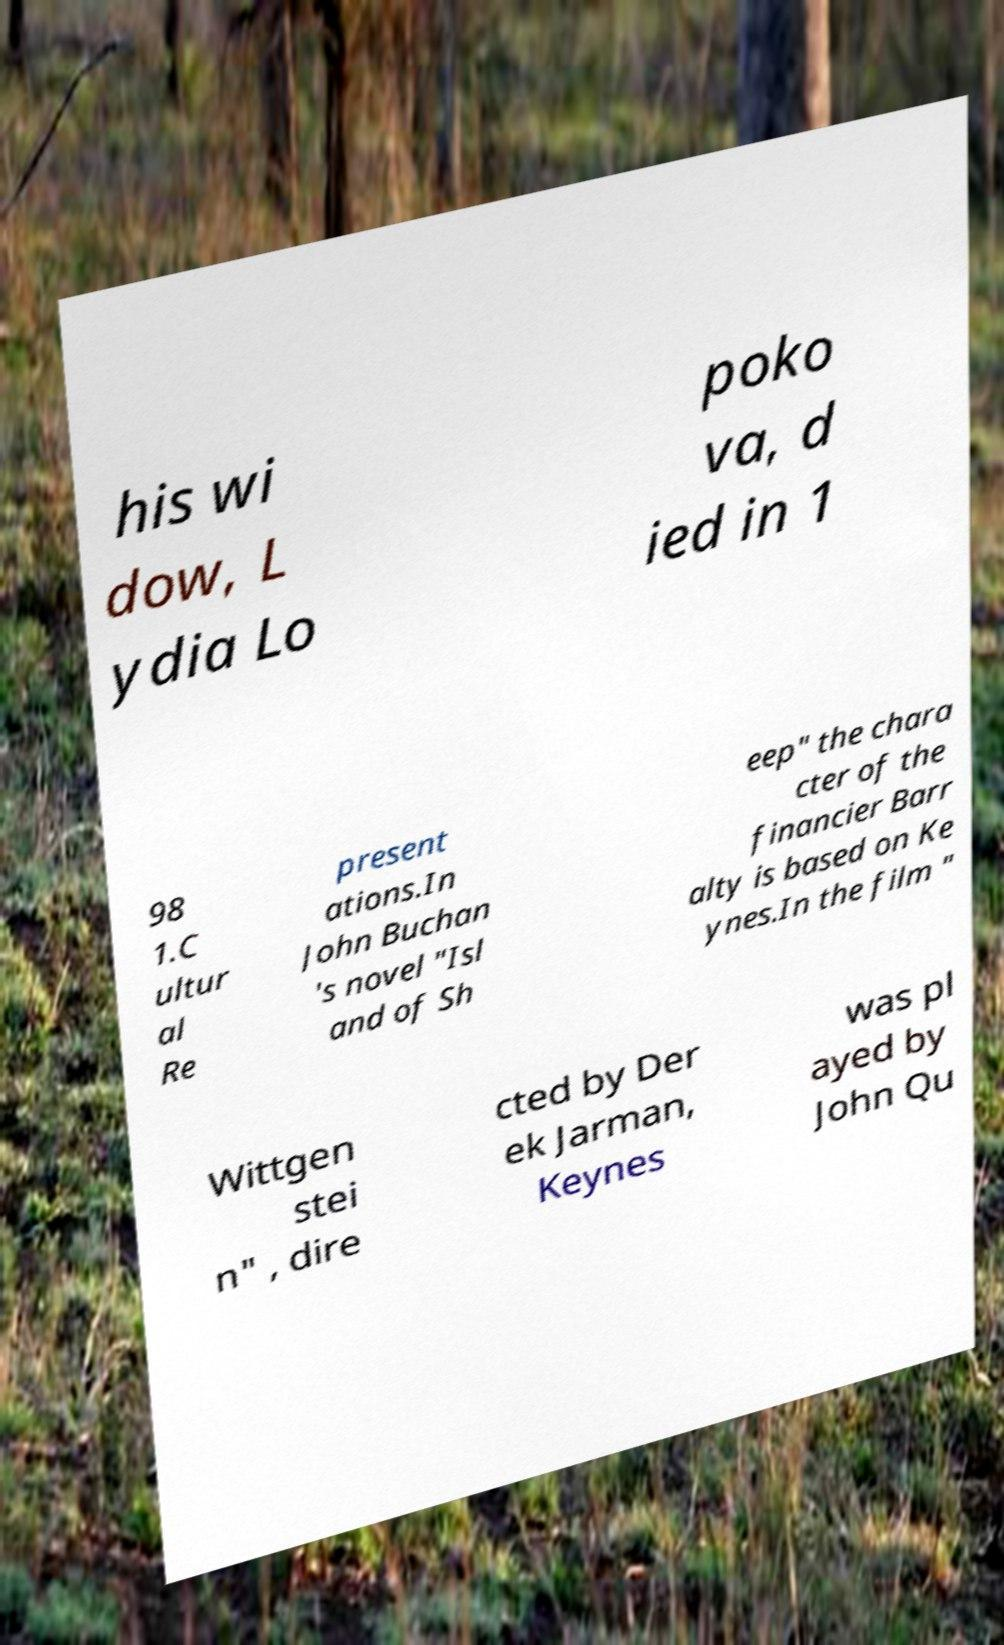Please identify and transcribe the text found in this image. his wi dow, L ydia Lo poko va, d ied in 1 98 1.C ultur al Re present ations.In John Buchan 's novel "Isl and of Sh eep" the chara cter of the financier Barr alty is based on Ke ynes.In the film " Wittgen stei n" , dire cted by Der ek Jarman, Keynes was pl ayed by John Qu 